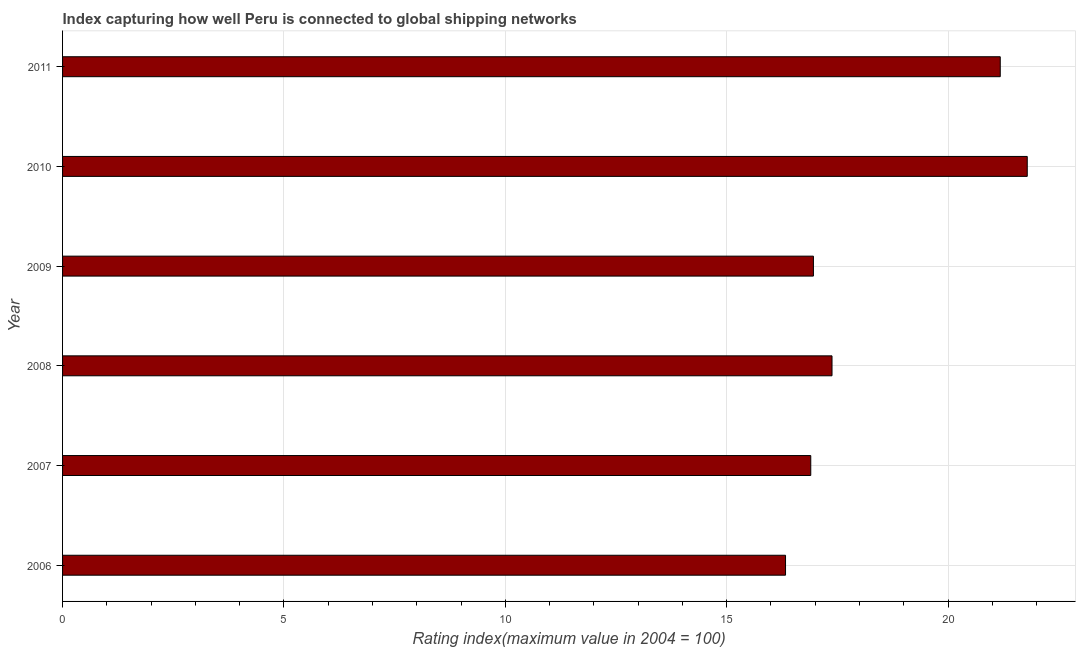What is the title of the graph?
Your answer should be very brief. Index capturing how well Peru is connected to global shipping networks. What is the label or title of the X-axis?
Provide a succinct answer. Rating index(maximum value in 2004 = 100). What is the label or title of the Y-axis?
Your answer should be very brief. Year. Across all years, what is the maximum liner shipping connectivity index?
Provide a succinct answer. 21.79. Across all years, what is the minimum liner shipping connectivity index?
Offer a very short reply. 16.33. In which year was the liner shipping connectivity index minimum?
Provide a short and direct response. 2006. What is the sum of the liner shipping connectivity index?
Provide a short and direct response. 110.54. What is the difference between the liner shipping connectivity index in 2006 and 2010?
Give a very brief answer. -5.46. What is the average liner shipping connectivity index per year?
Your answer should be very brief. 18.42. What is the median liner shipping connectivity index?
Offer a terse response. 17.17. Do a majority of the years between 2009 and 2011 (inclusive) have liner shipping connectivity index greater than 3 ?
Your response must be concise. Yes. What is the ratio of the liner shipping connectivity index in 2008 to that in 2011?
Your answer should be compact. 0.82. Is the liner shipping connectivity index in 2007 less than that in 2009?
Offer a terse response. Yes. Is the difference between the liner shipping connectivity index in 2008 and 2010 greater than the difference between any two years?
Offer a terse response. No. What is the difference between the highest and the second highest liner shipping connectivity index?
Offer a terse response. 0.61. What is the difference between the highest and the lowest liner shipping connectivity index?
Ensure brevity in your answer.  5.46. In how many years, is the liner shipping connectivity index greater than the average liner shipping connectivity index taken over all years?
Make the answer very short. 2. How many years are there in the graph?
Your response must be concise. 6. Are the values on the major ticks of X-axis written in scientific E-notation?
Your response must be concise. No. What is the Rating index(maximum value in 2004 = 100) of 2006?
Ensure brevity in your answer.  16.33. What is the Rating index(maximum value in 2004 = 100) of 2007?
Make the answer very short. 16.9. What is the Rating index(maximum value in 2004 = 100) of 2008?
Your answer should be very brief. 17.38. What is the Rating index(maximum value in 2004 = 100) in 2009?
Keep it short and to the point. 16.96. What is the Rating index(maximum value in 2004 = 100) of 2010?
Give a very brief answer. 21.79. What is the Rating index(maximum value in 2004 = 100) of 2011?
Your response must be concise. 21.18. What is the difference between the Rating index(maximum value in 2004 = 100) in 2006 and 2007?
Your answer should be compact. -0.57. What is the difference between the Rating index(maximum value in 2004 = 100) in 2006 and 2008?
Your answer should be compact. -1.05. What is the difference between the Rating index(maximum value in 2004 = 100) in 2006 and 2009?
Provide a short and direct response. -0.63. What is the difference between the Rating index(maximum value in 2004 = 100) in 2006 and 2010?
Offer a terse response. -5.46. What is the difference between the Rating index(maximum value in 2004 = 100) in 2006 and 2011?
Offer a terse response. -4.85. What is the difference between the Rating index(maximum value in 2004 = 100) in 2007 and 2008?
Offer a terse response. -0.48. What is the difference between the Rating index(maximum value in 2004 = 100) in 2007 and 2009?
Your response must be concise. -0.06. What is the difference between the Rating index(maximum value in 2004 = 100) in 2007 and 2010?
Provide a succinct answer. -4.89. What is the difference between the Rating index(maximum value in 2004 = 100) in 2007 and 2011?
Provide a succinct answer. -4.28. What is the difference between the Rating index(maximum value in 2004 = 100) in 2008 and 2009?
Make the answer very short. 0.42. What is the difference between the Rating index(maximum value in 2004 = 100) in 2008 and 2010?
Provide a short and direct response. -4.41. What is the difference between the Rating index(maximum value in 2004 = 100) in 2008 and 2011?
Your response must be concise. -3.8. What is the difference between the Rating index(maximum value in 2004 = 100) in 2009 and 2010?
Provide a succinct answer. -4.83. What is the difference between the Rating index(maximum value in 2004 = 100) in 2009 and 2011?
Make the answer very short. -4.22. What is the difference between the Rating index(maximum value in 2004 = 100) in 2010 and 2011?
Provide a succinct answer. 0.61. What is the ratio of the Rating index(maximum value in 2004 = 100) in 2006 to that in 2009?
Your answer should be compact. 0.96. What is the ratio of the Rating index(maximum value in 2004 = 100) in 2006 to that in 2010?
Your response must be concise. 0.75. What is the ratio of the Rating index(maximum value in 2004 = 100) in 2006 to that in 2011?
Make the answer very short. 0.77. What is the ratio of the Rating index(maximum value in 2004 = 100) in 2007 to that in 2010?
Ensure brevity in your answer.  0.78. What is the ratio of the Rating index(maximum value in 2004 = 100) in 2007 to that in 2011?
Your answer should be very brief. 0.8. What is the ratio of the Rating index(maximum value in 2004 = 100) in 2008 to that in 2010?
Your answer should be compact. 0.8. What is the ratio of the Rating index(maximum value in 2004 = 100) in 2008 to that in 2011?
Your answer should be compact. 0.82. What is the ratio of the Rating index(maximum value in 2004 = 100) in 2009 to that in 2010?
Provide a succinct answer. 0.78. What is the ratio of the Rating index(maximum value in 2004 = 100) in 2009 to that in 2011?
Ensure brevity in your answer.  0.8. 